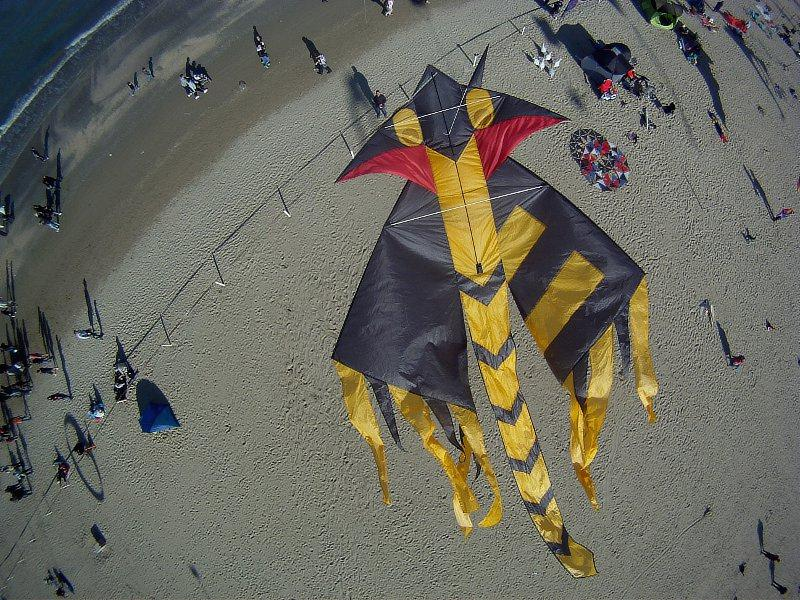Question: what kind of drone camera?
Choices:
A. A Panasonic.
B. A Fuji.
C. An HP.
D. Maybe a go pro.
Answer with the letter. Answer: D Question: where is the target of the shot?
Choices:
A. The sailboat.
B. The picnic.
C. The park.
D. The beach.
Answer with the letter. Answer: D Question: what type of kite is it?
Choices:
A. Glider.
B. Red.
C. Box.
D. Phantom.
Answer with the letter. Answer: D Question: what eagle eye view is this?
Choices:
A. From the bluff.
B. From the plane.
C. A drone camera.
D. From a hang-glider.
Answer with the letter. Answer: C Question: what color is the kite?
Choices:
A. Black and silver.
B. Red, yellow and black.
C. Gold, green and black.
D. Pink, silver and black.
Answer with the letter. Answer: B Question: where was the photo taken?
Choices:
A. At the river.
B. The park.
C. On a beach.
D. The roller coaster.
Answer with the letter. Answer: C Question: what kind of lens is the photo shot with?
Choices:
A. A curved fish-eye lens.
B. A short one.
C. A shaded lense.
D. A broken lense.
Answer with the letter. Answer: A Question: what is on the kite?
Choices:
A. Eyes.
B. The tail.
C. String.
D. A handle.
Answer with the letter. Answer: A Question: what does the kite fly above?
Choices:
A. The clouds.
B. A sandy beach.
C. The trees.
D. The house.
Answer with the letter. Answer: B Question: what angle was this picture taken from?
Choices:
A. From the air.
B. From the ground level.
C. From the stands.
D. From the saddle.
Answer with the letter. Answer: A Question: why is the shoreline wet?
Choices:
A. Thats where the water and beach meet.
B. The waves just crashed the rocks.
C. The tide just came in.
D. The sun has not dried it out yet.
Answer with the letter. Answer: A Question: what is the colorful kite doing?
Choices:
A. Falling out of the sky.
B. Flying away.
C. Flying above the sandy beach.
D. Spins.
Answer with the letter. Answer: C Question: what kind of prints are in the sand?
Choices:
A. Footprints.
B. Dog prints.
C. Prints that the waves made.
D. Tire.
Answer with the letter. Answer: A 